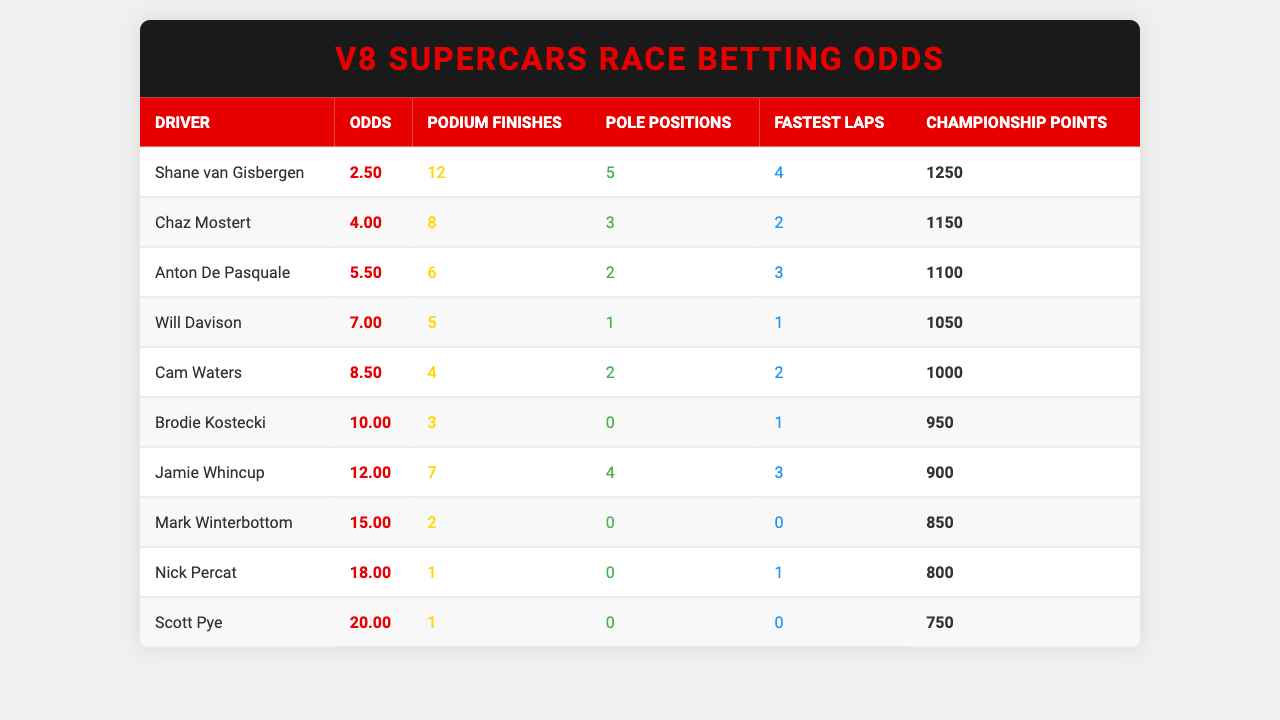What are the betting odds for Shane van Gisbergen? The table lists the odds for each driver, and for Shane van Gisbergen, it shows 2.50.
Answer: 2.50 Who has the most podium finishes among the top 10 drivers? The table provides the number of podium finishes for each driver, and Shane van Gisbergen has the highest with 12.
Answer: Shane van Gisbergen Which driver has the lowest betting odds? From the odds column, the driver with the lowest odds is Shane van Gisbergen at 2.50.
Answer: Shane van Gisbergen How many total podium finishes do the top 10 drivers have combined? We sum the podium finishes: 12 + 8 + 6 + 5 + 4 + 3 + 7 + 2 + 1 + 1 = 49.
Answer: 49 Is it true that Will Davison has more pole positions than Cam Waters? Will Davison has 1 pole position and Cam Waters has 2. Thus, the statement is false.
Answer: No What is the average number of fastest laps among the top 10 drivers? We calculate the sum of fastest laps: 4 + 2 + 3 + 1 + 2 + 1 + 3 + 0 + 1 + 0 = 17, and then divide by 10, giving 17 / 10 = 1.7.
Answer: 1.7 Which driver has the highest number of championship points? The table shows championship points, and Shane van Gisbergen has the highest with 1250 points.
Answer: Shane van Gisbergen What is the difference in odds between the top and bottom-ranked drivers? The top-ranked driver (Shane van Gisbergen) has odds of 2.50, and the bottom (Scott Pye) has odds of 20.00. The difference is 20.00 - 2.50 = 17.50.
Answer: 17.50 Does any driver have the same number of fastest laps? Both Scott Pye and Mark Winterbottom have 0 fastest laps; therefore, yes, they share this statistic.
Answer: Yes What is the combined championship points of the top three drivers? The points for the top three drivers are 1250 (Shane van Gisbergen) + 1150 (Chaz Mostert) + 1100 (Anton De Pasquale) = 3500.
Answer: 3500 